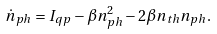Convert formula to latex. <formula><loc_0><loc_0><loc_500><loc_500>\dot { n } _ { p h } = I _ { q p } - \beta n _ { p h } ^ { 2 } - 2 \beta n _ { t h } n _ { p h } .</formula> 